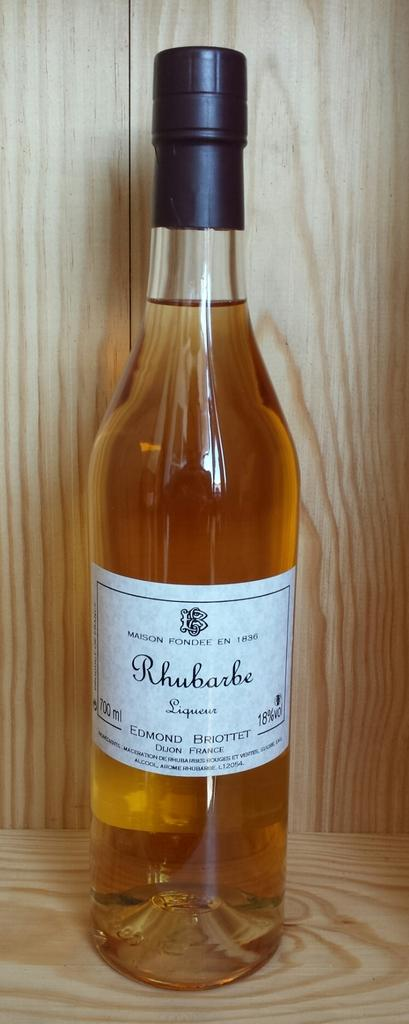What is inside the bottle that is visible in the image? The bottle contains a drink. Is there any additional information about the bottle? Yes, there is a sticker on the bottle. What is the status of the bottle's cap? The cap of the bottle is closed. On what surface is the bottle placed? The bottle is placed on a wooden platform. How does the growth of the pie affect the prison in the image? There is no growth, pie, or prison present in the image. 